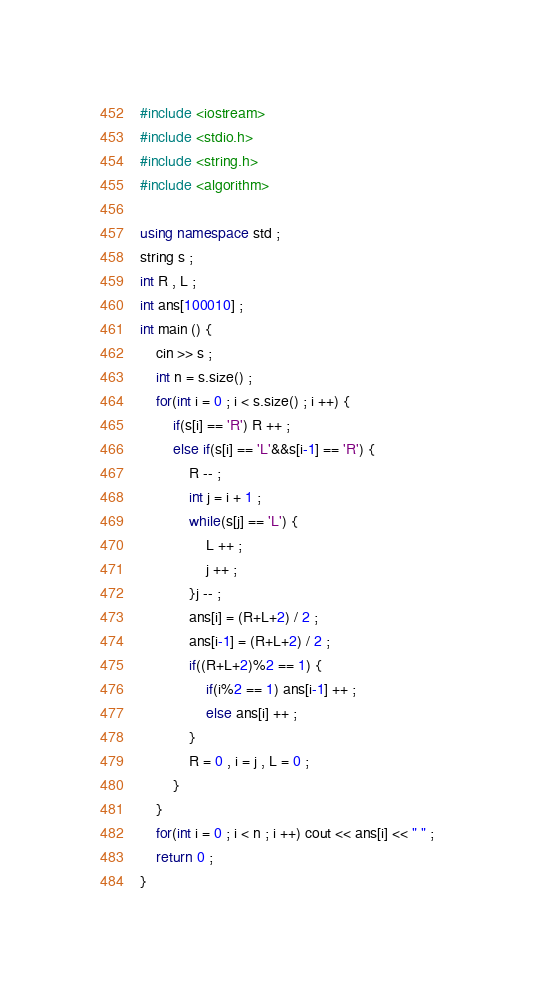<code> <loc_0><loc_0><loc_500><loc_500><_C++_>#include <iostream>
#include <stdio.h>
#include <string.h>
#include <algorithm>

using namespace std ;
string s ;
int R , L ;
int ans[100010] ;
int main () {
	cin >> s ;
	int n = s.size() ;
	for(int i = 0 ; i < s.size() ; i ++) {
		if(s[i] == 'R') R ++ ;
		else if(s[i] == 'L'&&s[i-1] == 'R') {
			R -- ;
			int j = i + 1 ;
			while(s[j] == 'L') {
				L ++ ;
				j ++ ;
			}j -- ;
			ans[i] = (R+L+2) / 2 ;
			ans[i-1] = (R+L+2) / 2 ;
			if((R+L+2)%2 == 1) {
				if(i%2 == 1) ans[i-1] ++ ;
				else ans[i] ++ ;
			}
			R = 0 , i = j , L = 0 ;
		}
	}
	for(int i = 0 ; i < n ; i ++) cout << ans[i] << " " ;
	return 0 ;
} </code> 